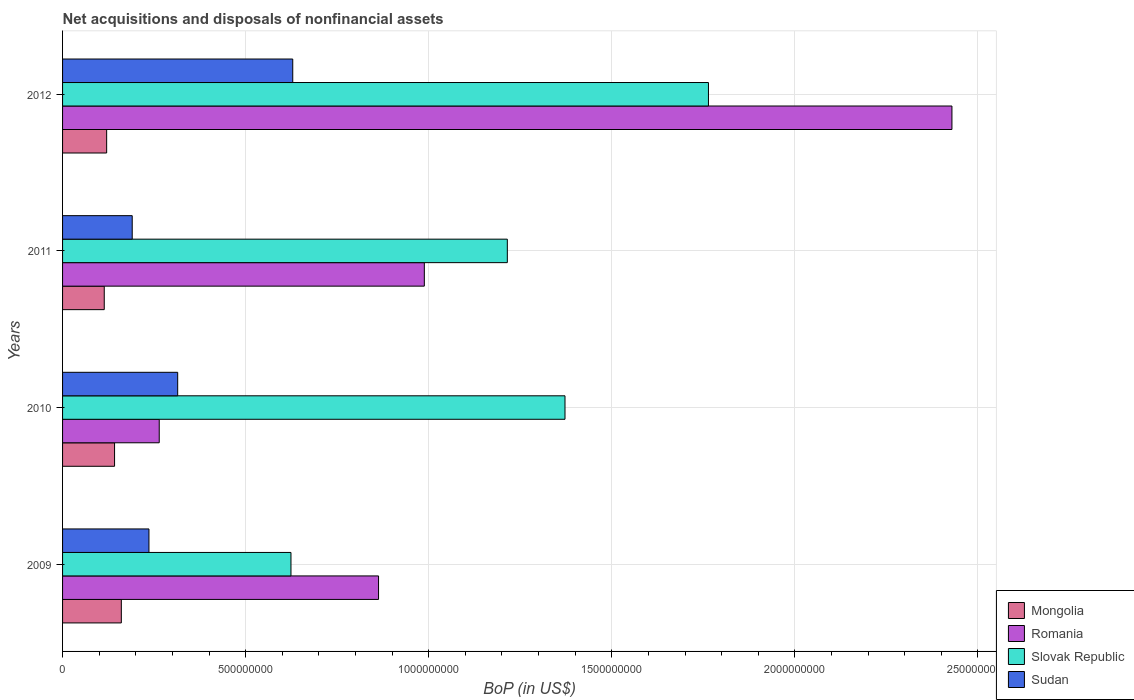How many groups of bars are there?
Give a very brief answer. 4. Are the number of bars per tick equal to the number of legend labels?
Ensure brevity in your answer.  Yes. Are the number of bars on each tick of the Y-axis equal?
Ensure brevity in your answer.  Yes. How many bars are there on the 1st tick from the bottom?
Offer a very short reply. 4. In how many cases, is the number of bars for a given year not equal to the number of legend labels?
Make the answer very short. 0. What is the Balance of Payments in Slovak Republic in 2010?
Offer a terse response. 1.37e+09. Across all years, what is the maximum Balance of Payments in Sudan?
Offer a terse response. 6.29e+08. Across all years, what is the minimum Balance of Payments in Slovak Republic?
Make the answer very short. 6.24e+08. In which year was the Balance of Payments in Mongolia maximum?
Provide a succinct answer. 2009. What is the total Balance of Payments in Sudan in the graph?
Keep it short and to the point. 1.37e+09. What is the difference between the Balance of Payments in Mongolia in 2009 and that in 2012?
Give a very brief answer. 4.01e+07. What is the difference between the Balance of Payments in Romania in 2009 and the Balance of Payments in Slovak Republic in 2012?
Your answer should be compact. -9.01e+08. What is the average Balance of Payments in Slovak Republic per year?
Give a very brief answer. 1.24e+09. In the year 2012, what is the difference between the Balance of Payments in Slovak Republic and Balance of Payments in Sudan?
Give a very brief answer. 1.14e+09. What is the ratio of the Balance of Payments in Romania in 2009 to that in 2011?
Ensure brevity in your answer.  0.87. What is the difference between the highest and the second highest Balance of Payments in Slovak Republic?
Provide a succinct answer. 3.92e+08. What is the difference between the highest and the lowest Balance of Payments in Slovak Republic?
Keep it short and to the point. 1.14e+09. In how many years, is the Balance of Payments in Mongolia greater than the average Balance of Payments in Mongolia taken over all years?
Your answer should be very brief. 2. What does the 2nd bar from the top in 2009 represents?
Make the answer very short. Slovak Republic. What does the 3rd bar from the bottom in 2010 represents?
Make the answer very short. Slovak Republic. How many bars are there?
Offer a terse response. 16. Are the values on the major ticks of X-axis written in scientific E-notation?
Ensure brevity in your answer.  No. Does the graph contain any zero values?
Your answer should be compact. No. What is the title of the graph?
Offer a very short reply. Net acquisitions and disposals of nonfinancial assets. Does "Eritrea" appear as one of the legend labels in the graph?
Your answer should be very brief. No. What is the label or title of the X-axis?
Your answer should be compact. BoP (in US$). What is the BoP (in US$) in Mongolia in 2009?
Offer a terse response. 1.60e+08. What is the BoP (in US$) of Romania in 2009?
Offer a very short reply. 8.63e+08. What is the BoP (in US$) of Slovak Republic in 2009?
Keep it short and to the point. 6.24e+08. What is the BoP (in US$) in Sudan in 2009?
Provide a short and direct response. 2.36e+08. What is the BoP (in US$) of Mongolia in 2010?
Ensure brevity in your answer.  1.42e+08. What is the BoP (in US$) of Romania in 2010?
Ensure brevity in your answer.  2.64e+08. What is the BoP (in US$) of Slovak Republic in 2010?
Make the answer very short. 1.37e+09. What is the BoP (in US$) of Sudan in 2010?
Offer a terse response. 3.14e+08. What is the BoP (in US$) of Mongolia in 2011?
Keep it short and to the point. 1.14e+08. What is the BoP (in US$) in Romania in 2011?
Provide a succinct answer. 9.88e+08. What is the BoP (in US$) in Slovak Republic in 2011?
Provide a short and direct response. 1.21e+09. What is the BoP (in US$) of Sudan in 2011?
Make the answer very short. 1.90e+08. What is the BoP (in US$) in Mongolia in 2012?
Keep it short and to the point. 1.20e+08. What is the BoP (in US$) of Romania in 2012?
Provide a short and direct response. 2.43e+09. What is the BoP (in US$) of Slovak Republic in 2012?
Ensure brevity in your answer.  1.76e+09. What is the BoP (in US$) in Sudan in 2012?
Provide a succinct answer. 6.29e+08. Across all years, what is the maximum BoP (in US$) of Mongolia?
Offer a very short reply. 1.60e+08. Across all years, what is the maximum BoP (in US$) in Romania?
Ensure brevity in your answer.  2.43e+09. Across all years, what is the maximum BoP (in US$) of Slovak Republic?
Offer a terse response. 1.76e+09. Across all years, what is the maximum BoP (in US$) in Sudan?
Keep it short and to the point. 6.29e+08. Across all years, what is the minimum BoP (in US$) in Mongolia?
Ensure brevity in your answer.  1.14e+08. Across all years, what is the minimum BoP (in US$) in Romania?
Keep it short and to the point. 2.64e+08. Across all years, what is the minimum BoP (in US$) in Slovak Republic?
Offer a very short reply. 6.24e+08. Across all years, what is the minimum BoP (in US$) in Sudan?
Provide a succinct answer. 1.90e+08. What is the total BoP (in US$) in Mongolia in the graph?
Provide a succinct answer. 5.37e+08. What is the total BoP (in US$) of Romania in the graph?
Give a very brief answer. 4.54e+09. What is the total BoP (in US$) of Slovak Republic in the graph?
Your response must be concise. 4.97e+09. What is the total BoP (in US$) of Sudan in the graph?
Keep it short and to the point. 1.37e+09. What is the difference between the BoP (in US$) in Mongolia in 2009 and that in 2010?
Your answer should be compact. 1.85e+07. What is the difference between the BoP (in US$) of Romania in 2009 and that in 2010?
Provide a short and direct response. 5.99e+08. What is the difference between the BoP (in US$) in Slovak Republic in 2009 and that in 2010?
Ensure brevity in your answer.  -7.48e+08. What is the difference between the BoP (in US$) of Sudan in 2009 and that in 2010?
Provide a succinct answer. -7.85e+07. What is the difference between the BoP (in US$) of Mongolia in 2009 and that in 2011?
Give a very brief answer. 4.66e+07. What is the difference between the BoP (in US$) in Romania in 2009 and that in 2011?
Offer a very short reply. -1.25e+08. What is the difference between the BoP (in US$) in Slovak Republic in 2009 and that in 2011?
Your answer should be very brief. -5.91e+08. What is the difference between the BoP (in US$) of Sudan in 2009 and that in 2011?
Make the answer very short. 4.57e+07. What is the difference between the BoP (in US$) in Mongolia in 2009 and that in 2012?
Ensure brevity in your answer.  4.01e+07. What is the difference between the BoP (in US$) of Romania in 2009 and that in 2012?
Keep it short and to the point. -1.57e+09. What is the difference between the BoP (in US$) in Slovak Republic in 2009 and that in 2012?
Provide a short and direct response. -1.14e+09. What is the difference between the BoP (in US$) of Sudan in 2009 and that in 2012?
Make the answer very short. -3.93e+08. What is the difference between the BoP (in US$) of Mongolia in 2010 and that in 2011?
Your answer should be compact. 2.81e+07. What is the difference between the BoP (in US$) of Romania in 2010 and that in 2011?
Provide a short and direct response. -7.24e+08. What is the difference between the BoP (in US$) in Slovak Republic in 2010 and that in 2011?
Keep it short and to the point. 1.58e+08. What is the difference between the BoP (in US$) in Sudan in 2010 and that in 2011?
Your response must be concise. 1.24e+08. What is the difference between the BoP (in US$) of Mongolia in 2010 and that in 2012?
Keep it short and to the point. 2.16e+07. What is the difference between the BoP (in US$) in Romania in 2010 and that in 2012?
Ensure brevity in your answer.  -2.16e+09. What is the difference between the BoP (in US$) in Slovak Republic in 2010 and that in 2012?
Your response must be concise. -3.92e+08. What is the difference between the BoP (in US$) in Sudan in 2010 and that in 2012?
Offer a terse response. -3.14e+08. What is the difference between the BoP (in US$) in Mongolia in 2011 and that in 2012?
Keep it short and to the point. -6.56e+06. What is the difference between the BoP (in US$) of Romania in 2011 and that in 2012?
Offer a terse response. -1.44e+09. What is the difference between the BoP (in US$) in Slovak Republic in 2011 and that in 2012?
Your answer should be very brief. -5.49e+08. What is the difference between the BoP (in US$) of Sudan in 2011 and that in 2012?
Your answer should be very brief. -4.38e+08. What is the difference between the BoP (in US$) in Mongolia in 2009 and the BoP (in US$) in Romania in 2010?
Offer a terse response. -1.04e+08. What is the difference between the BoP (in US$) of Mongolia in 2009 and the BoP (in US$) of Slovak Republic in 2010?
Provide a succinct answer. -1.21e+09. What is the difference between the BoP (in US$) in Mongolia in 2009 and the BoP (in US$) in Sudan in 2010?
Provide a short and direct response. -1.54e+08. What is the difference between the BoP (in US$) of Romania in 2009 and the BoP (in US$) of Slovak Republic in 2010?
Offer a very short reply. -5.09e+08. What is the difference between the BoP (in US$) in Romania in 2009 and the BoP (in US$) in Sudan in 2010?
Provide a succinct answer. 5.49e+08. What is the difference between the BoP (in US$) of Slovak Republic in 2009 and the BoP (in US$) of Sudan in 2010?
Your answer should be compact. 3.09e+08. What is the difference between the BoP (in US$) of Mongolia in 2009 and the BoP (in US$) of Romania in 2011?
Provide a short and direct response. -8.28e+08. What is the difference between the BoP (in US$) of Mongolia in 2009 and the BoP (in US$) of Slovak Republic in 2011?
Make the answer very short. -1.05e+09. What is the difference between the BoP (in US$) in Mongolia in 2009 and the BoP (in US$) in Sudan in 2011?
Offer a terse response. -2.97e+07. What is the difference between the BoP (in US$) of Romania in 2009 and the BoP (in US$) of Slovak Republic in 2011?
Your response must be concise. -3.52e+08. What is the difference between the BoP (in US$) of Romania in 2009 and the BoP (in US$) of Sudan in 2011?
Make the answer very short. 6.73e+08. What is the difference between the BoP (in US$) in Slovak Republic in 2009 and the BoP (in US$) in Sudan in 2011?
Your response must be concise. 4.34e+08. What is the difference between the BoP (in US$) of Mongolia in 2009 and the BoP (in US$) of Romania in 2012?
Your response must be concise. -2.27e+09. What is the difference between the BoP (in US$) in Mongolia in 2009 and the BoP (in US$) in Slovak Republic in 2012?
Your response must be concise. -1.60e+09. What is the difference between the BoP (in US$) of Mongolia in 2009 and the BoP (in US$) of Sudan in 2012?
Ensure brevity in your answer.  -4.68e+08. What is the difference between the BoP (in US$) in Romania in 2009 and the BoP (in US$) in Slovak Republic in 2012?
Give a very brief answer. -9.01e+08. What is the difference between the BoP (in US$) in Romania in 2009 and the BoP (in US$) in Sudan in 2012?
Provide a succinct answer. 2.34e+08. What is the difference between the BoP (in US$) in Slovak Republic in 2009 and the BoP (in US$) in Sudan in 2012?
Your answer should be compact. -4.89e+06. What is the difference between the BoP (in US$) of Mongolia in 2010 and the BoP (in US$) of Romania in 2011?
Provide a short and direct response. -8.46e+08. What is the difference between the BoP (in US$) in Mongolia in 2010 and the BoP (in US$) in Slovak Republic in 2011?
Provide a succinct answer. -1.07e+09. What is the difference between the BoP (in US$) in Mongolia in 2010 and the BoP (in US$) in Sudan in 2011?
Your answer should be compact. -4.82e+07. What is the difference between the BoP (in US$) in Romania in 2010 and the BoP (in US$) in Slovak Republic in 2011?
Keep it short and to the point. -9.51e+08. What is the difference between the BoP (in US$) in Romania in 2010 and the BoP (in US$) in Sudan in 2011?
Give a very brief answer. 7.38e+07. What is the difference between the BoP (in US$) of Slovak Republic in 2010 and the BoP (in US$) of Sudan in 2011?
Offer a terse response. 1.18e+09. What is the difference between the BoP (in US$) in Mongolia in 2010 and the BoP (in US$) in Romania in 2012?
Give a very brief answer. -2.29e+09. What is the difference between the BoP (in US$) in Mongolia in 2010 and the BoP (in US$) in Slovak Republic in 2012?
Provide a short and direct response. -1.62e+09. What is the difference between the BoP (in US$) in Mongolia in 2010 and the BoP (in US$) in Sudan in 2012?
Your answer should be very brief. -4.87e+08. What is the difference between the BoP (in US$) in Romania in 2010 and the BoP (in US$) in Slovak Republic in 2012?
Provide a succinct answer. -1.50e+09. What is the difference between the BoP (in US$) of Romania in 2010 and the BoP (in US$) of Sudan in 2012?
Your answer should be compact. -3.65e+08. What is the difference between the BoP (in US$) in Slovak Republic in 2010 and the BoP (in US$) in Sudan in 2012?
Provide a short and direct response. 7.44e+08. What is the difference between the BoP (in US$) of Mongolia in 2011 and the BoP (in US$) of Romania in 2012?
Your answer should be compact. -2.32e+09. What is the difference between the BoP (in US$) of Mongolia in 2011 and the BoP (in US$) of Slovak Republic in 2012?
Make the answer very short. -1.65e+09. What is the difference between the BoP (in US$) in Mongolia in 2011 and the BoP (in US$) in Sudan in 2012?
Make the answer very short. -5.15e+08. What is the difference between the BoP (in US$) of Romania in 2011 and the BoP (in US$) of Slovak Republic in 2012?
Provide a short and direct response. -7.76e+08. What is the difference between the BoP (in US$) in Romania in 2011 and the BoP (in US$) in Sudan in 2012?
Offer a terse response. 3.59e+08. What is the difference between the BoP (in US$) of Slovak Republic in 2011 and the BoP (in US$) of Sudan in 2012?
Make the answer very short. 5.86e+08. What is the average BoP (in US$) of Mongolia per year?
Your answer should be compact. 1.34e+08. What is the average BoP (in US$) in Romania per year?
Give a very brief answer. 1.14e+09. What is the average BoP (in US$) of Slovak Republic per year?
Offer a very short reply. 1.24e+09. What is the average BoP (in US$) of Sudan per year?
Provide a short and direct response. 3.42e+08. In the year 2009, what is the difference between the BoP (in US$) of Mongolia and BoP (in US$) of Romania?
Offer a terse response. -7.03e+08. In the year 2009, what is the difference between the BoP (in US$) of Mongolia and BoP (in US$) of Slovak Republic?
Provide a short and direct response. -4.63e+08. In the year 2009, what is the difference between the BoP (in US$) of Mongolia and BoP (in US$) of Sudan?
Provide a succinct answer. -7.54e+07. In the year 2009, what is the difference between the BoP (in US$) in Romania and BoP (in US$) in Slovak Republic?
Make the answer very short. 2.39e+08. In the year 2009, what is the difference between the BoP (in US$) of Romania and BoP (in US$) of Sudan?
Ensure brevity in your answer.  6.27e+08. In the year 2009, what is the difference between the BoP (in US$) in Slovak Republic and BoP (in US$) in Sudan?
Your answer should be very brief. 3.88e+08. In the year 2010, what is the difference between the BoP (in US$) in Mongolia and BoP (in US$) in Romania?
Your answer should be compact. -1.22e+08. In the year 2010, what is the difference between the BoP (in US$) in Mongolia and BoP (in US$) in Slovak Republic?
Keep it short and to the point. -1.23e+09. In the year 2010, what is the difference between the BoP (in US$) in Mongolia and BoP (in US$) in Sudan?
Your response must be concise. -1.72e+08. In the year 2010, what is the difference between the BoP (in US$) of Romania and BoP (in US$) of Slovak Republic?
Provide a succinct answer. -1.11e+09. In the year 2010, what is the difference between the BoP (in US$) in Romania and BoP (in US$) in Sudan?
Give a very brief answer. -5.04e+07. In the year 2010, what is the difference between the BoP (in US$) in Slovak Republic and BoP (in US$) in Sudan?
Make the answer very short. 1.06e+09. In the year 2011, what is the difference between the BoP (in US$) of Mongolia and BoP (in US$) of Romania?
Your answer should be compact. -8.74e+08. In the year 2011, what is the difference between the BoP (in US$) of Mongolia and BoP (in US$) of Slovak Republic?
Give a very brief answer. -1.10e+09. In the year 2011, what is the difference between the BoP (in US$) in Mongolia and BoP (in US$) in Sudan?
Offer a terse response. -7.64e+07. In the year 2011, what is the difference between the BoP (in US$) of Romania and BoP (in US$) of Slovak Republic?
Ensure brevity in your answer.  -2.27e+08. In the year 2011, what is the difference between the BoP (in US$) in Romania and BoP (in US$) in Sudan?
Your response must be concise. 7.98e+08. In the year 2011, what is the difference between the BoP (in US$) of Slovak Republic and BoP (in US$) of Sudan?
Ensure brevity in your answer.  1.02e+09. In the year 2012, what is the difference between the BoP (in US$) of Mongolia and BoP (in US$) of Romania?
Offer a very short reply. -2.31e+09. In the year 2012, what is the difference between the BoP (in US$) in Mongolia and BoP (in US$) in Slovak Republic?
Provide a short and direct response. -1.64e+09. In the year 2012, what is the difference between the BoP (in US$) of Mongolia and BoP (in US$) of Sudan?
Your answer should be very brief. -5.08e+08. In the year 2012, what is the difference between the BoP (in US$) in Romania and BoP (in US$) in Slovak Republic?
Keep it short and to the point. 6.65e+08. In the year 2012, what is the difference between the BoP (in US$) of Romania and BoP (in US$) of Sudan?
Provide a short and direct response. 1.80e+09. In the year 2012, what is the difference between the BoP (in US$) of Slovak Republic and BoP (in US$) of Sudan?
Your response must be concise. 1.14e+09. What is the ratio of the BoP (in US$) of Mongolia in 2009 to that in 2010?
Your answer should be very brief. 1.13. What is the ratio of the BoP (in US$) in Romania in 2009 to that in 2010?
Provide a succinct answer. 3.27. What is the ratio of the BoP (in US$) in Slovak Republic in 2009 to that in 2010?
Offer a very short reply. 0.45. What is the ratio of the BoP (in US$) in Sudan in 2009 to that in 2010?
Ensure brevity in your answer.  0.75. What is the ratio of the BoP (in US$) of Mongolia in 2009 to that in 2011?
Ensure brevity in your answer.  1.41. What is the ratio of the BoP (in US$) of Romania in 2009 to that in 2011?
Keep it short and to the point. 0.87. What is the ratio of the BoP (in US$) of Slovak Republic in 2009 to that in 2011?
Your response must be concise. 0.51. What is the ratio of the BoP (in US$) of Sudan in 2009 to that in 2011?
Your answer should be compact. 1.24. What is the ratio of the BoP (in US$) in Mongolia in 2009 to that in 2012?
Keep it short and to the point. 1.33. What is the ratio of the BoP (in US$) of Romania in 2009 to that in 2012?
Offer a terse response. 0.36. What is the ratio of the BoP (in US$) of Slovak Republic in 2009 to that in 2012?
Provide a succinct answer. 0.35. What is the ratio of the BoP (in US$) of Sudan in 2009 to that in 2012?
Offer a very short reply. 0.38. What is the ratio of the BoP (in US$) of Mongolia in 2010 to that in 2011?
Your response must be concise. 1.25. What is the ratio of the BoP (in US$) in Romania in 2010 to that in 2011?
Offer a very short reply. 0.27. What is the ratio of the BoP (in US$) of Slovak Republic in 2010 to that in 2011?
Your response must be concise. 1.13. What is the ratio of the BoP (in US$) of Sudan in 2010 to that in 2011?
Offer a terse response. 1.65. What is the ratio of the BoP (in US$) of Mongolia in 2010 to that in 2012?
Your answer should be very brief. 1.18. What is the ratio of the BoP (in US$) in Romania in 2010 to that in 2012?
Ensure brevity in your answer.  0.11. What is the ratio of the BoP (in US$) of Slovak Republic in 2010 to that in 2012?
Your answer should be compact. 0.78. What is the ratio of the BoP (in US$) in Sudan in 2010 to that in 2012?
Offer a very short reply. 0.5. What is the ratio of the BoP (in US$) of Mongolia in 2011 to that in 2012?
Provide a short and direct response. 0.95. What is the ratio of the BoP (in US$) of Romania in 2011 to that in 2012?
Your response must be concise. 0.41. What is the ratio of the BoP (in US$) of Slovak Republic in 2011 to that in 2012?
Keep it short and to the point. 0.69. What is the ratio of the BoP (in US$) in Sudan in 2011 to that in 2012?
Your answer should be very brief. 0.3. What is the difference between the highest and the second highest BoP (in US$) of Mongolia?
Ensure brevity in your answer.  1.85e+07. What is the difference between the highest and the second highest BoP (in US$) in Romania?
Your answer should be very brief. 1.44e+09. What is the difference between the highest and the second highest BoP (in US$) in Slovak Republic?
Your response must be concise. 3.92e+08. What is the difference between the highest and the second highest BoP (in US$) of Sudan?
Provide a succinct answer. 3.14e+08. What is the difference between the highest and the lowest BoP (in US$) in Mongolia?
Provide a short and direct response. 4.66e+07. What is the difference between the highest and the lowest BoP (in US$) in Romania?
Your response must be concise. 2.16e+09. What is the difference between the highest and the lowest BoP (in US$) in Slovak Republic?
Make the answer very short. 1.14e+09. What is the difference between the highest and the lowest BoP (in US$) of Sudan?
Your answer should be compact. 4.38e+08. 